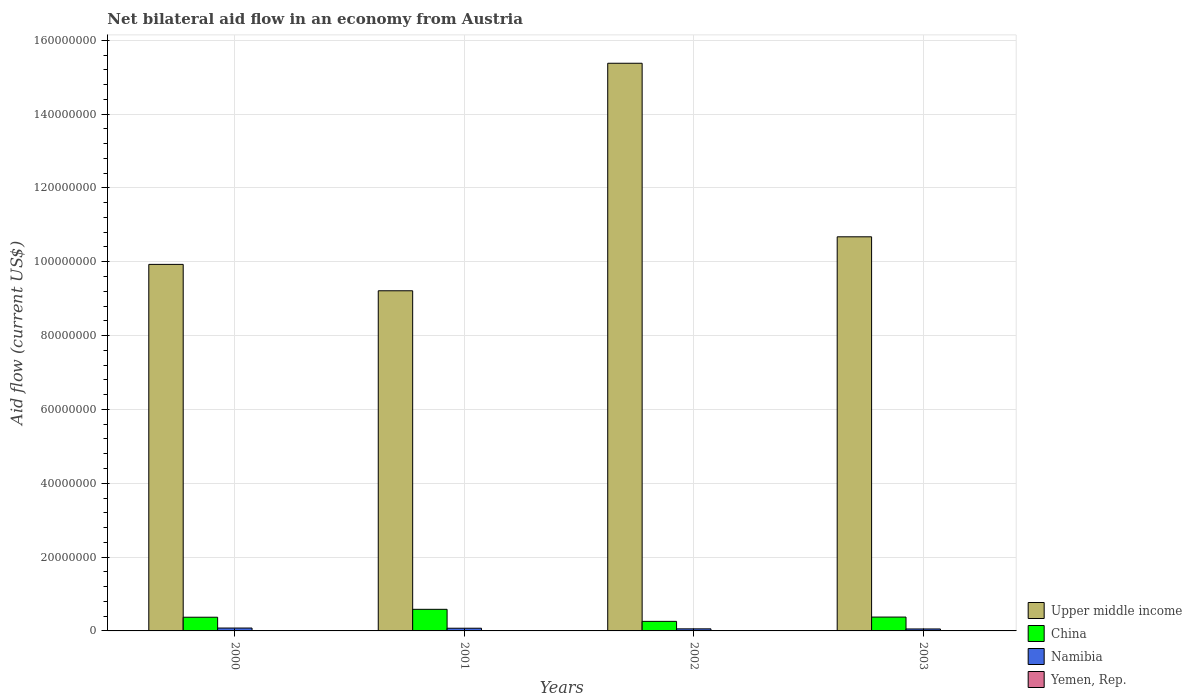How many bars are there on the 4th tick from the left?
Provide a short and direct response. 4. What is the net bilateral aid flow in Upper middle income in 2002?
Keep it short and to the point. 1.54e+08. Across all years, what is the maximum net bilateral aid flow in Yemen, Rep.?
Your response must be concise. 4.00e+04. Across all years, what is the minimum net bilateral aid flow in China?
Offer a very short reply. 2.59e+06. In which year was the net bilateral aid flow in Yemen, Rep. maximum?
Give a very brief answer. 2000. What is the total net bilateral aid flow in Upper middle income in the graph?
Keep it short and to the point. 4.52e+08. What is the difference between the net bilateral aid flow in Upper middle income in 2001 and that in 2002?
Keep it short and to the point. -6.16e+07. What is the difference between the net bilateral aid flow in China in 2003 and the net bilateral aid flow in Namibia in 2002?
Offer a terse response. 3.19e+06. What is the average net bilateral aid flow in Yemen, Rep. per year?
Ensure brevity in your answer.  3.50e+04. In the year 2000, what is the difference between the net bilateral aid flow in Namibia and net bilateral aid flow in China?
Your answer should be compact. -2.93e+06. In how many years, is the net bilateral aid flow in Upper middle income greater than 96000000 US$?
Keep it short and to the point. 3. What is the ratio of the net bilateral aid flow in Upper middle income in 2002 to that in 2003?
Provide a succinct answer. 1.44. Is the difference between the net bilateral aid flow in Namibia in 2002 and 2003 greater than the difference between the net bilateral aid flow in China in 2002 and 2003?
Offer a very short reply. Yes. What is the difference between the highest and the second highest net bilateral aid flow in Yemen, Rep.?
Make the answer very short. 0. Is it the case that in every year, the sum of the net bilateral aid flow in China and net bilateral aid flow in Yemen, Rep. is greater than the sum of net bilateral aid flow in Namibia and net bilateral aid flow in Upper middle income?
Make the answer very short. No. What does the 1st bar from the left in 2003 represents?
Your answer should be compact. Upper middle income. What does the 1st bar from the right in 2001 represents?
Your answer should be compact. Yemen, Rep. Are all the bars in the graph horizontal?
Provide a short and direct response. No. What is the difference between two consecutive major ticks on the Y-axis?
Your response must be concise. 2.00e+07. Are the values on the major ticks of Y-axis written in scientific E-notation?
Offer a terse response. No. What is the title of the graph?
Provide a short and direct response. Net bilateral aid flow in an economy from Austria. What is the label or title of the X-axis?
Ensure brevity in your answer.  Years. What is the label or title of the Y-axis?
Offer a terse response. Aid flow (current US$). What is the Aid flow (current US$) in Upper middle income in 2000?
Keep it short and to the point. 9.93e+07. What is the Aid flow (current US$) of China in 2000?
Ensure brevity in your answer.  3.71e+06. What is the Aid flow (current US$) in Namibia in 2000?
Ensure brevity in your answer.  7.80e+05. What is the Aid flow (current US$) of Upper middle income in 2001?
Make the answer very short. 9.21e+07. What is the Aid flow (current US$) in China in 2001?
Offer a very short reply. 5.85e+06. What is the Aid flow (current US$) in Namibia in 2001?
Provide a short and direct response. 7.30e+05. What is the Aid flow (current US$) of Upper middle income in 2002?
Your answer should be very brief. 1.54e+08. What is the Aid flow (current US$) of China in 2002?
Offer a terse response. 2.59e+06. What is the Aid flow (current US$) in Namibia in 2002?
Keep it short and to the point. 5.60e+05. What is the Aid flow (current US$) in Upper middle income in 2003?
Your answer should be compact. 1.07e+08. What is the Aid flow (current US$) in China in 2003?
Provide a succinct answer. 3.75e+06. What is the Aid flow (current US$) of Namibia in 2003?
Your answer should be very brief. 5.30e+05. What is the Aid flow (current US$) of Yemen, Rep. in 2003?
Provide a short and direct response. 4.00e+04. Across all years, what is the maximum Aid flow (current US$) of Upper middle income?
Offer a terse response. 1.54e+08. Across all years, what is the maximum Aid flow (current US$) in China?
Your answer should be very brief. 5.85e+06. Across all years, what is the maximum Aid flow (current US$) of Namibia?
Make the answer very short. 7.80e+05. Across all years, what is the maximum Aid flow (current US$) of Yemen, Rep.?
Provide a succinct answer. 4.00e+04. Across all years, what is the minimum Aid flow (current US$) in Upper middle income?
Provide a succinct answer. 9.21e+07. Across all years, what is the minimum Aid flow (current US$) of China?
Provide a succinct answer. 2.59e+06. Across all years, what is the minimum Aid flow (current US$) in Namibia?
Make the answer very short. 5.30e+05. What is the total Aid flow (current US$) of Upper middle income in the graph?
Ensure brevity in your answer.  4.52e+08. What is the total Aid flow (current US$) in China in the graph?
Your answer should be very brief. 1.59e+07. What is the total Aid flow (current US$) of Namibia in the graph?
Offer a very short reply. 2.60e+06. What is the difference between the Aid flow (current US$) in Upper middle income in 2000 and that in 2001?
Offer a terse response. 7.15e+06. What is the difference between the Aid flow (current US$) in China in 2000 and that in 2001?
Give a very brief answer. -2.14e+06. What is the difference between the Aid flow (current US$) in Upper middle income in 2000 and that in 2002?
Offer a very short reply. -5.45e+07. What is the difference between the Aid flow (current US$) in China in 2000 and that in 2002?
Your answer should be compact. 1.12e+06. What is the difference between the Aid flow (current US$) in Namibia in 2000 and that in 2002?
Offer a terse response. 2.20e+05. What is the difference between the Aid flow (current US$) of Yemen, Rep. in 2000 and that in 2002?
Make the answer very short. 10000. What is the difference between the Aid flow (current US$) in Upper middle income in 2000 and that in 2003?
Make the answer very short. -7.47e+06. What is the difference between the Aid flow (current US$) in Namibia in 2000 and that in 2003?
Provide a short and direct response. 2.50e+05. What is the difference between the Aid flow (current US$) in Upper middle income in 2001 and that in 2002?
Offer a terse response. -6.16e+07. What is the difference between the Aid flow (current US$) in China in 2001 and that in 2002?
Your answer should be compact. 3.26e+06. What is the difference between the Aid flow (current US$) of Namibia in 2001 and that in 2002?
Your response must be concise. 1.70e+05. What is the difference between the Aid flow (current US$) of Upper middle income in 2001 and that in 2003?
Provide a short and direct response. -1.46e+07. What is the difference between the Aid flow (current US$) of China in 2001 and that in 2003?
Ensure brevity in your answer.  2.10e+06. What is the difference between the Aid flow (current US$) of Namibia in 2001 and that in 2003?
Provide a short and direct response. 2.00e+05. What is the difference between the Aid flow (current US$) of Yemen, Rep. in 2001 and that in 2003?
Your response must be concise. -10000. What is the difference between the Aid flow (current US$) of Upper middle income in 2002 and that in 2003?
Your response must be concise. 4.70e+07. What is the difference between the Aid flow (current US$) of China in 2002 and that in 2003?
Provide a short and direct response. -1.16e+06. What is the difference between the Aid flow (current US$) of Namibia in 2002 and that in 2003?
Make the answer very short. 3.00e+04. What is the difference between the Aid flow (current US$) in Upper middle income in 2000 and the Aid flow (current US$) in China in 2001?
Provide a succinct answer. 9.34e+07. What is the difference between the Aid flow (current US$) in Upper middle income in 2000 and the Aid flow (current US$) in Namibia in 2001?
Keep it short and to the point. 9.86e+07. What is the difference between the Aid flow (current US$) of Upper middle income in 2000 and the Aid flow (current US$) of Yemen, Rep. in 2001?
Your answer should be very brief. 9.93e+07. What is the difference between the Aid flow (current US$) in China in 2000 and the Aid flow (current US$) in Namibia in 2001?
Keep it short and to the point. 2.98e+06. What is the difference between the Aid flow (current US$) in China in 2000 and the Aid flow (current US$) in Yemen, Rep. in 2001?
Ensure brevity in your answer.  3.68e+06. What is the difference between the Aid flow (current US$) in Namibia in 2000 and the Aid flow (current US$) in Yemen, Rep. in 2001?
Offer a very short reply. 7.50e+05. What is the difference between the Aid flow (current US$) in Upper middle income in 2000 and the Aid flow (current US$) in China in 2002?
Offer a very short reply. 9.67e+07. What is the difference between the Aid flow (current US$) of Upper middle income in 2000 and the Aid flow (current US$) of Namibia in 2002?
Your answer should be very brief. 9.87e+07. What is the difference between the Aid flow (current US$) of Upper middle income in 2000 and the Aid flow (current US$) of Yemen, Rep. in 2002?
Offer a terse response. 9.93e+07. What is the difference between the Aid flow (current US$) of China in 2000 and the Aid flow (current US$) of Namibia in 2002?
Offer a very short reply. 3.15e+06. What is the difference between the Aid flow (current US$) of China in 2000 and the Aid flow (current US$) of Yemen, Rep. in 2002?
Give a very brief answer. 3.68e+06. What is the difference between the Aid flow (current US$) in Namibia in 2000 and the Aid flow (current US$) in Yemen, Rep. in 2002?
Provide a succinct answer. 7.50e+05. What is the difference between the Aid flow (current US$) in Upper middle income in 2000 and the Aid flow (current US$) in China in 2003?
Your answer should be very brief. 9.55e+07. What is the difference between the Aid flow (current US$) of Upper middle income in 2000 and the Aid flow (current US$) of Namibia in 2003?
Your answer should be very brief. 9.88e+07. What is the difference between the Aid flow (current US$) in Upper middle income in 2000 and the Aid flow (current US$) in Yemen, Rep. in 2003?
Provide a succinct answer. 9.92e+07. What is the difference between the Aid flow (current US$) of China in 2000 and the Aid flow (current US$) of Namibia in 2003?
Offer a terse response. 3.18e+06. What is the difference between the Aid flow (current US$) in China in 2000 and the Aid flow (current US$) in Yemen, Rep. in 2003?
Give a very brief answer. 3.67e+06. What is the difference between the Aid flow (current US$) in Namibia in 2000 and the Aid flow (current US$) in Yemen, Rep. in 2003?
Provide a succinct answer. 7.40e+05. What is the difference between the Aid flow (current US$) of Upper middle income in 2001 and the Aid flow (current US$) of China in 2002?
Ensure brevity in your answer.  8.96e+07. What is the difference between the Aid flow (current US$) of Upper middle income in 2001 and the Aid flow (current US$) of Namibia in 2002?
Offer a terse response. 9.16e+07. What is the difference between the Aid flow (current US$) in Upper middle income in 2001 and the Aid flow (current US$) in Yemen, Rep. in 2002?
Your answer should be very brief. 9.21e+07. What is the difference between the Aid flow (current US$) in China in 2001 and the Aid flow (current US$) in Namibia in 2002?
Offer a very short reply. 5.29e+06. What is the difference between the Aid flow (current US$) in China in 2001 and the Aid flow (current US$) in Yemen, Rep. in 2002?
Provide a short and direct response. 5.82e+06. What is the difference between the Aid flow (current US$) in Namibia in 2001 and the Aid flow (current US$) in Yemen, Rep. in 2002?
Your answer should be very brief. 7.00e+05. What is the difference between the Aid flow (current US$) in Upper middle income in 2001 and the Aid flow (current US$) in China in 2003?
Provide a succinct answer. 8.84e+07. What is the difference between the Aid flow (current US$) in Upper middle income in 2001 and the Aid flow (current US$) in Namibia in 2003?
Give a very brief answer. 9.16e+07. What is the difference between the Aid flow (current US$) in Upper middle income in 2001 and the Aid flow (current US$) in Yemen, Rep. in 2003?
Your answer should be very brief. 9.21e+07. What is the difference between the Aid flow (current US$) in China in 2001 and the Aid flow (current US$) in Namibia in 2003?
Offer a very short reply. 5.32e+06. What is the difference between the Aid flow (current US$) in China in 2001 and the Aid flow (current US$) in Yemen, Rep. in 2003?
Ensure brevity in your answer.  5.81e+06. What is the difference between the Aid flow (current US$) of Namibia in 2001 and the Aid flow (current US$) of Yemen, Rep. in 2003?
Provide a short and direct response. 6.90e+05. What is the difference between the Aid flow (current US$) of Upper middle income in 2002 and the Aid flow (current US$) of China in 2003?
Your response must be concise. 1.50e+08. What is the difference between the Aid flow (current US$) of Upper middle income in 2002 and the Aid flow (current US$) of Namibia in 2003?
Your answer should be very brief. 1.53e+08. What is the difference between the Aid flow (current US$) in Upper middle income in 2002 and the Aid flow (current US$) in Yemen, Rep. in 2003?
Ensure brevity in your answer.  1.54e+08. What is the difference between the Aid flow (current US$) of China in 2002 and the Aid flow (current US$) of Namibia in 2003?
Give a very brief answer. 2.06e+06. What is the difference between the Aid flow (current US$) of China in 2002 and the Aid flow (current US$) of Yemen, Rep. in 2003?
Make the answer very short. 2.55e+06. What is the difference between the Aid flow (current US$) of Namibia in 2002 and the Aid flow (current US$) of Yemen, Rep. in 2003?
Provide a short and direct response. 5.20e+05. What is the average Aid flow (current US$) of Upper middle income per year?
Provide a short and direct response. 1.13e+08. What is the average Aid flow (current US$) in China per year?
Your response must be concise. 3.98e+06. What is the average Aid flow (current US$) in Namibia per year?
Ensure brevity in your answer.  6.50e+05. What is the average Aid flow (current US$) in Yemen, Rep. per year?
Ensure brevity in your answer.  3.50e+04. In the year 2000, what is the difference between the Aid flow (current US$) of Upper middle income and Aid flow (current US$) of China?
Your answer should be very brief. 9.56e+07. In the year 2000, what is the difference between the Aid flow (current US$) in Upper middle income and Aid flow (current US$) in Namibia?
Your answer should be compact. 9.85e+07. In the year 2000, what is the difference between the Aid flow (current US$) in Upper middle income and Aid flow (current US$) in Yemen, Rep.?
Ensure brevity in your answer.  9.92e+07. In the year 2000, what is the difference between the Aid flow (current US$) in China and Aid flow (current US$) in Namibia?
Your response must be concise. 2.93e+06. In the year 2000, what is the difference between the Aid flow (current US$) of China and Aid flow (current US$) of Yemen, Rep.?
Give a very brief answer. 3.67e+06. In the year 2000, what is the difference between the Aid flow (current US$) in Namibia and Aid flow (current US$) in Yemen, Rep.?
Your answer should be compact. 7.40e+05. In the year 2001, what is the difference between the Aid flow (current US$) in Upper middle income and Aid flow (current US$) in China?
Ensure brevity in your answer.  8.63e+07. In the year 2001, what is the difference between the Aid flow (current US$) of Upper middle income and Aid flow (current US$) of Namibia?
Your answer should be compact. 9.14e+07. In the year 2001, what is the difference between the Aid flow (current US$) of Upper middle income and Aid flow (current US$) of Yemen, Rep.?
Provide a succinct answer. 9.21e+07. In the year 2001, what is the difference between the Aid flow (current US$) of China and Aid flow (current US$) of Namibia?
Give a very brief answer. 5.12e+06. In the year 2001, what is the difference between the Aid flow (current US$) of China and Aid flow (current US$) of Yemen, Rep.?
Provide a short and direct response. 5.82e+06. In the year 2001, what is the difference between the Aid flow (current US$) in Namibia and Aid flow (current US$) in Yemen, Rep.?
Make the answer very short. 7.00e+05. In the year 2002, what is the difference between the Aid flow (current US$) of Upper middle income and Aid flow (current US$) of China?
Ensure brevity in your answer.  1.51e+08. In the year 2002, what is the difference between the Aid flow (current US$) in Upper middle income and Aid flow (current US$) in Namibia?
Offer a terse response. 1.53e+08. In the year 2002, what is the difference between the Aid flow (current US$) in Upper middle income and Aid flow (current US$) in Yemen, Rep.?
Provide a succinct answer. 1.54e+08. In the year 2002, what is the difference between the Aid flow (current US$) in China and Aid flow (current US$) in Namibia?
Make the answer very short. 2.03e+06. In the year 2002, what is the difference between the Aid flow (current US$) in China and Aid flow (current US$) in Yemen, Rep.?
Your response must be concise. 2.56e+06. In the year 2002, what is the difference between the Aid flow (current US$) in Namibia and Aid flow (current US$) in Yemen, Rep.?
Offer a terse response. 5.30e+05. In the year 2003, what is the difference between the Aid flow (current US$) in Upper middle income and Aid flow (current US$) in China?
Make the answer very short. 1.03e+08. In the year 2003, what is the difference between the Aid flow (current US$) of Upper middle income and Aid flow (current US$) of Namibia?
Your answer should be very brief. 1.06e+08. In the year 2003, what is the difference between the Aid flow (current US$) of Upper middle income and Aid flow (current US$) of Yemen, Rep.?
Your response must be concise. 1.07e+08. In the year 2003, what is the difference between the Aid flow (current US$) in China and Aid flow (current US$) in Namibia?
Your answer should be compact. 3.22e+06. In the year 2003, what is the difference between the Aid flow (current US$) of China and Aid flow (current US$) of Yemen, Rep.?
Provide a succinct answer. 3.71e+06. What is the ratio of the Aid flow (current US$) of Upper middle income in 2000 to that in 2001?
Your answer should be compact. 1.08. What is the ratio of the Aid flow (current US$) of China in 2000 to that in 2001?
Your answer should be very brief. 0.63. What is the ratio of the Aid flow (current US$) in Namibia in 2000 to that in 2001?
Your answer should be very brief. 1.07. What is the ratio of the Aid flow (current US$) in Yemen, Rep. in 2000 to that in 2001?
Your answer should be compact. 1.33. What is the ratio of the Aid flow (current US$) of Upper middle income in 2000 to that in 2002?
Your answer should be compact. 0.65. What is the ratio of the Aid flow (current US$) of China in 2000 to that in 2002?
Offer a terse response. 1.43. What is the ratio of the Aid flow (current US$) of Namibia in 2000 to that in 2002?
Offer a very short reply. 1.39. What is the ratio of the Aid flow (current US$) of China in 2000 to that in 2003?
Your answer should be compact. 0.99. What is the ratio of the Aid flow (current US$) of Namibia in 2000 to that in 2003?
Your response must be concise. 1.47. What is the ratio of the Aid flow (current US$) in Upper middle income in 2001 to that in 2002?
Provide a short and direct response. 0.6. What is the ratio of the Aid flow (current US$) in China in 2001 to that in 2002?
Give a very brief answer. 2.26. What is the ratio of the Aid flow (current US$) in Namibia in 2001 to that in 2002?
Make the answer very short. 1.3. What is the ratio of the Aid flow (current US$) of Yemen, Rep. in 2001 to that in 2002?
Your answer should be very brief. 1. What is the ratio of the Aid flow (current US$) in Upper middle income in 2001 to that in 2003?
Your answer should be compact. 0.86. What is the ratio of the Aid flow (current US$) of China in 2001 to that in 2003?
Offer a terse response. 1.56. What is the ratio of the Aid flow (current US$) in Namibia in 2001 to that in 2003?
Make the answer very short. 1.38. What is the ratio of the Aid flow (current US$) in Yemen, Rep. in 2001 to that in 2003?
Make the answer very short. 0.75. What is the ratio of the Aid flow (current US$) in Upper middle income in 2002 to that in 2003?
Provide a short and direct response. 1.44. What is the ratio of the Aid flow (current US$) in China in 2002 to that in 2003?
Give a very brief answer. 0.69. What is the ratio of the Aid flow (current US$) in Namibia in 2002 to that in 2003?
Keep it short and to the point. 1.06. What is the ratio of the Aid flow (current US$) of Yemen, Rep. in 2002 to that in 2003?
Make the answer very short. 0.75. What is the difference between the highest and the second highest Aid flow (current US$) in Upper middle income?
Ensure brevity in your answer.  4.70e+07. What is the difference between the highest and the second highest Aid flow (current US$) of China?
Provide a succinct answer. 2.10e+06. What is the difference between the highest and the second highest Aid flow (current US$) of Namibia?
Make the answer very short. 5.00e+04. What is the difference between the highest and the lowest Aid flow (current US$) of Upper middle income?
Offer a terse response. 6.16e+07. What is the difference between the highest and the lowest Aid flow (current US$) in China?
Offer a terse response. 3.26e+06. What is the difference between the highest and the lowest Aid flow (current US$) in Namibia?
Provide a short and direct response. 2.50e+05. What is the difference between the highest and the lowest Aid flow (current US$) in Yemen, Rep.?
Your answer should be very brief. 10000. 